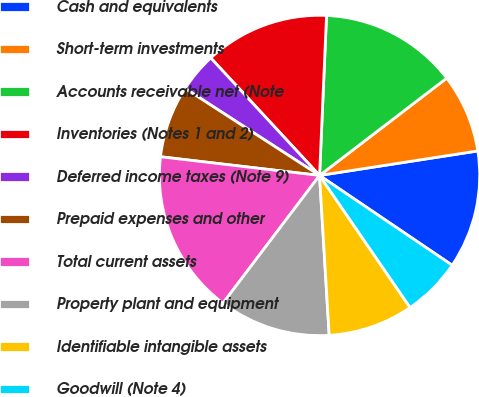<chart> <loc_0><loc_0><loc_500><loc_500><pie_chart><fcel>Cash and equivalents<fcel>Short-term investments<fcel>Accounts receivable net (Note<fcel>Inventories (Notes 1 and 2)<fcel>Deferred income taxes (Note 9)<fcel>Prepaid expenses and other<fcel>Total current assets<fcel>Property plant and equipment<fcel>Identifiable intangible assets<fcel>Goodwill (Note 4)<nl><fcel>11.92%<fcel>7.95%<fcel>13.91%<fcel>12.58%<fcel>3.97%<fcel>7.28%<fcel>16.56%<fcel>11.26%<fcel>8.61%<fcel>5.96%<nl></chart> 